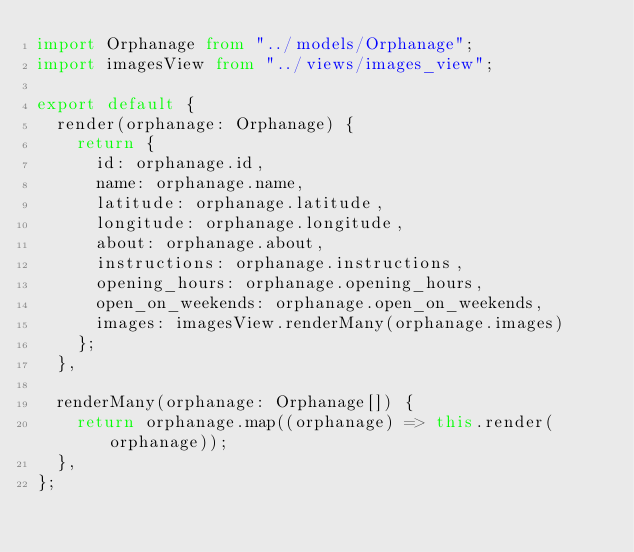Convert code to text. <code><loc_0><loc_0><loc_500><loc_500><_TypeScript_>import Orphanage from "../models/Orphanage";
import imagesView from "../views/images_view";

export default {
  render(orphanage: Orphanage) {
    return {
      id: orphanage.id,
      name: orphanage.name,
      latitude: orphanage.latitude,
      longitude: orphanage.longitude,
      about: orphanage.about,
      instructions: orphanage.instructions,
      opening_hours: orphanage.opening_hours,
      open_on_weekends: orphanage.open_on_weekends,
      images: imagesView.renderMany(orphanage.images)
    };
  },

  renderMany(orphanage: Orphanage[]) {
    return orphanage.map((orphanage) => this.render(orphanage));
  },
};
</code> 